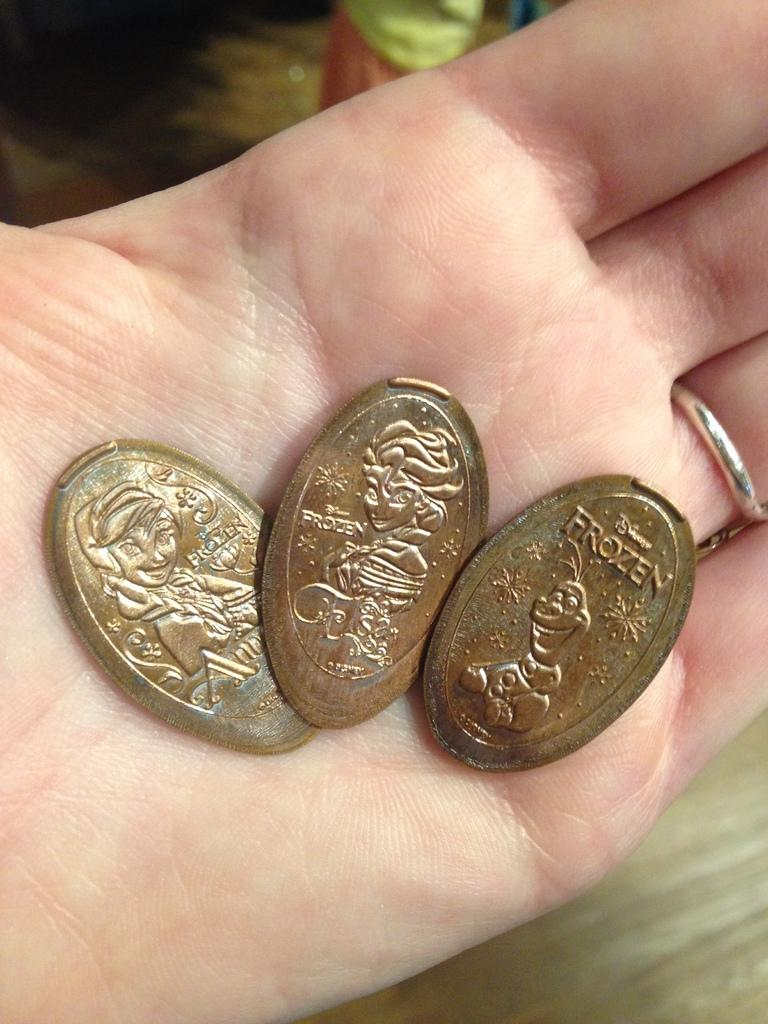Provide a one-sentence caption for the provided image. several Frozen bronze coins are in a person's hand. 